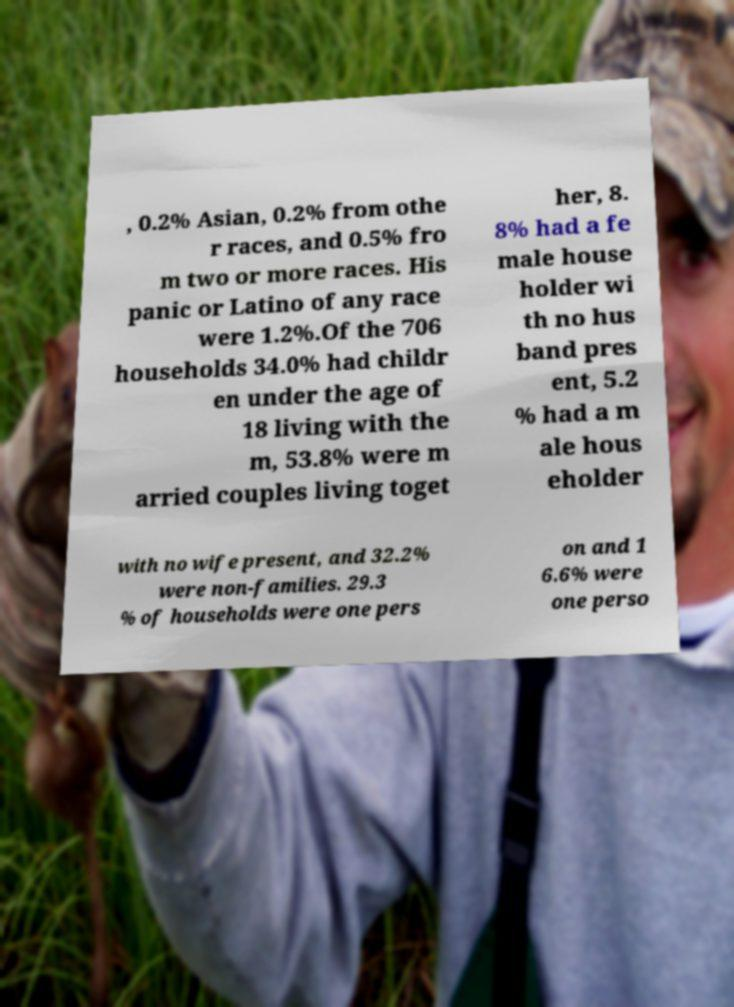I need the written content from this picture converted into text. Can you do that? , 0.2% Asian, 0.2% from othe r races, and 0.5% fro m two or more races. His panic or Latino of any race were 1.2%.Of the 706 households 34.0% had childr en under the age of 18 living with the m, 53.8% were m arried couples living toget her, 8. 8% had a fe male house holder wi th no hus band pres ent, 5.2 % had a m ale hous eholder with no wife present, and 32.2% were non-families. 29.3 % of households were one pers on and 1 6.6% were one perso 